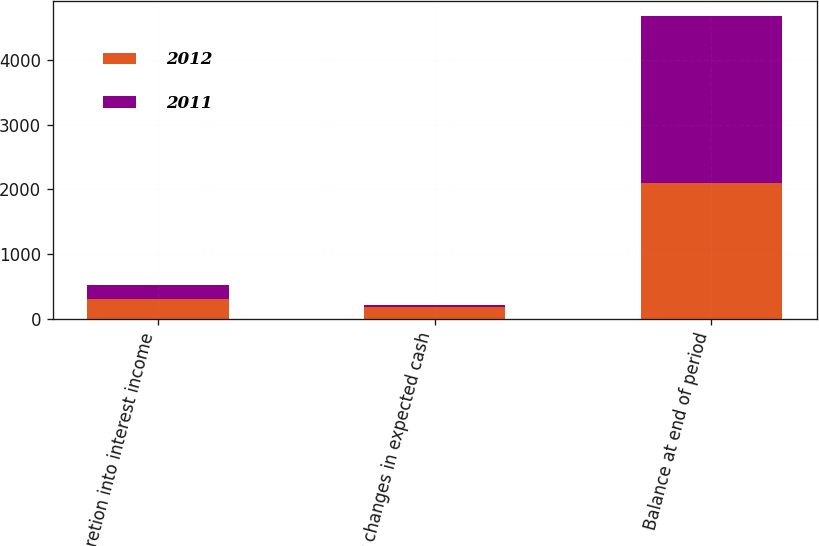Convert chart to OTSL. <chart><loc_0><loc_0><loc_500><loc_500><stacked_bar_chart><ecel><fcel>Accretion into interest income<fcel>Other changes in expected cash<fcel>Balance at end of period<nl><fcel>2012<fcel>303<fcel>181<fcel>2096<nl><fcel>2011<fcel>225<fcel>30<fcel>2580<nl></chart> 